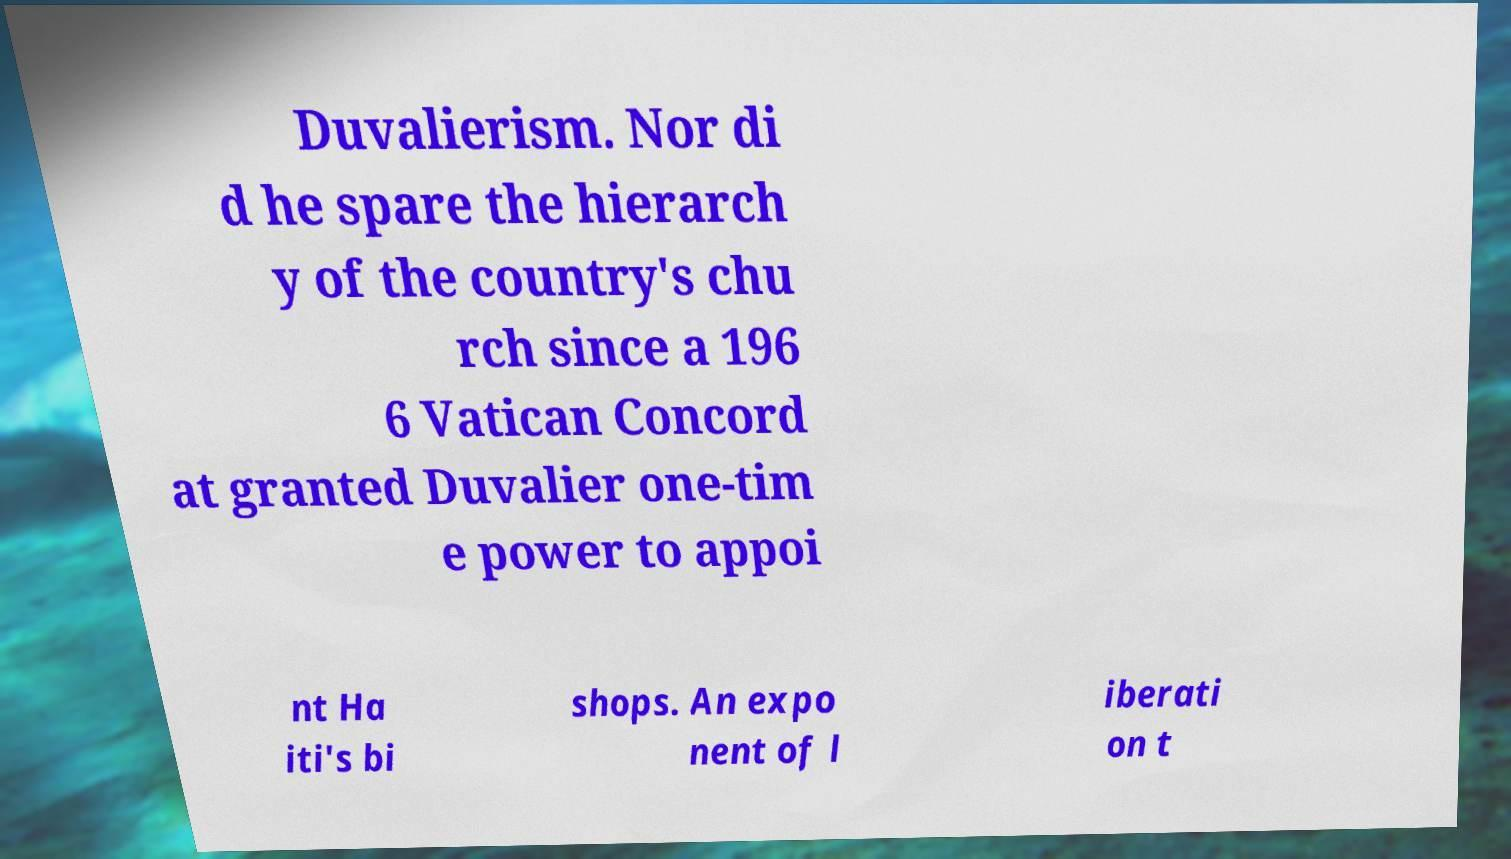There's text embedded in this image that I need extracted. Can you transcribe it verbatim? Duvalierism. Nor di d he spare the hierarch y of the country's chu rch since a 196 6 Vatican Concord at granted Duvalier one-tim e power to appoi nt Ha iti's bi shops. An expo nent of l iberati on t 